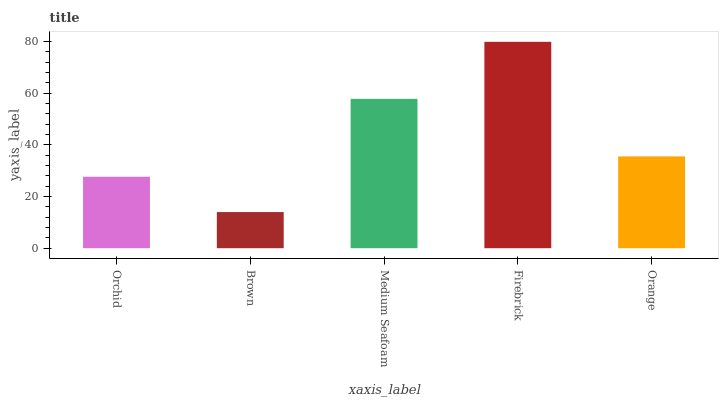Is Brown the minimum?
Answer yes or no. Yes. Is Firebrick the maximum?
Answer yes or no. Yes. Is Medium Seafoam the minimum?
Answer yes or no. No. Is Medium Seafoam the maximum?
Answer yes or no. No. Is Medium Seafoam greater than Brown?
Answer yes or no. Yes. Is Brown less than Medium Seafoam?
Answer yes or no. Yes. Is Brown greater than Medium Seafoam?
Answer yes or no. No. Is Medium Seafoam less than Brown?
Answer yes or no. No. Is Orange the high median?
Answer yes or no. Yes. Is Orange the low median?
Answer yes or no. Yes. Is Medium Seafoam the high median?
Answer yes or no. No. Is Orchid the low median?
Answer yes or no. No. 